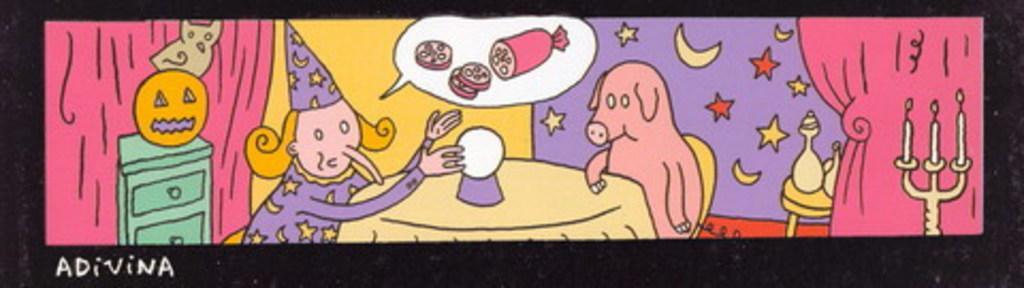Describe this image in one or two sentences. In the picture we can see a painting with a cartoon play with a table and near to it, we can see a woman and a pig sitting and besides, we can see a wall with some painting of stars and the moon and besides we can see some curtain on the wall and a candle stand with candles. 